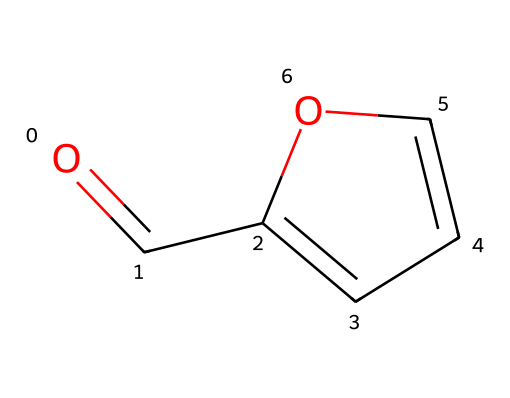What is the molecular formula of this compound? To determine the molecular formula, we count the number of each type of atom from the structure represented by the SMILES. The structure corresponds to one carbonyl group (C=O) and a carbon ring containing four carbon atoms and one oxygen atom. Thus, the total count is 5 carbons, 6 hydrogens, and 1 oxygen. This gives us the molecular formula C5H6O.
Answer: C5H6O How many carbon atoms are in furfural? By examining the SMILES notation, we can visualize that there are a total of 5 carbon atoms in the compound. The structure of the molecule indicates that all carbon atoms are part of the ring or branched structure.
Answer: 5 What functional group is present in furfural? Furfural contains a carbonyl group, which consists of a carbon atom double-bonded to an oxygen atom (C=O). This is characteristic of ketones, confirming that the functional group present here is a carbonyl.
Answer: carbonyl What type of ring does furfural contain? The SMILES representation shows that furfural has a five-membered ring structure, specifically a furan ring, which contains four carbon atoms and one oxygen atom in a cyclic formation.
Answer: furan Is furfural a saturated or unsaturated compound? To determine if a compound is saturated or unsaturated, we check for the presence of double bonds. Furfural features a double bond in the carbonyl (C=O) and further indicates unsaturation in the ring system. Therefore, furfural is an unsaturated compound.
Answer: unsaturated What is the significance of furfural in historical manuscripts? Furfural is significant because it is a byproduct of cellulose degradation as paper ages, and its presence can serve as an indicator of the condition and aging process of historical manuscripts, allowing for assessments of their integrity and preservation.
Answer: condition indicator 